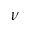<formula> <loc_0><loc_0><loc_500><loc_500>\nu</formula> 